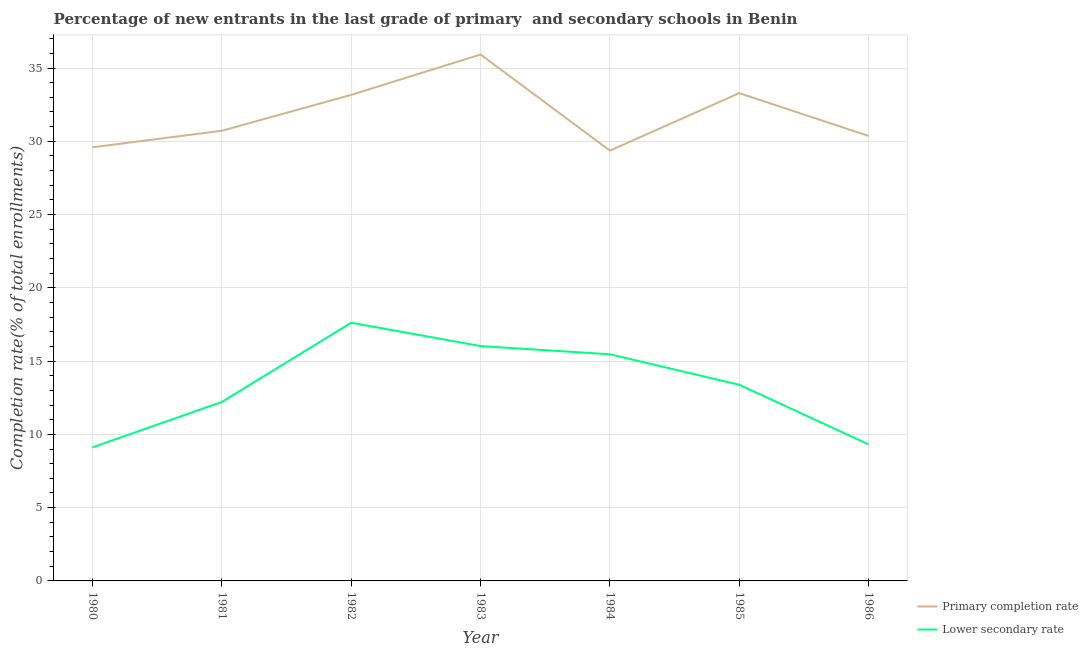How many different coloured lines are there?
Your answer should be compact. 2. Does the line corresponding to completion rate in primary schools intersect with the line corresponding to completion rate in secondary schools?
Provide a short and direct response. No. What is the completion rate in secondary schools in 1980?
Your response must be concise. 9.12. Across all years, what is the maximum completion rate in secondary schools?
Provide a succinct answer. 17.62. Across all years, what is the minimum completion rate in primary schools?
Provide a short and direct response. 29.36. In which year was the completion rate in primary schools maximum?
Ensure brevity in your answer.  1983. What is the total completion rate in secondary schools in the graph?
Offer a very short reply. 93.14. What is the difference between the completion rate in primary schools in 1980 and that in 1982?
Your answer should be compact. -3.58. What is the difference between the completion rate in secondary schools in 1980 and the completion rate in primary schools in 1984?
Offer a very short reply. -20.25. What is the average completion rate in primary schools per year?
Offer a terse response. 31.77. In the year 1981, what is the difference between the completion rate in secondary schools and completion rate in primary schools?
Give a very brief answer. -18.51. What is the ratio of the completion rate in primary schools in 1980 to that in 1981?
Keep it short and to the point. 0.96. Is the completion rate in secondary schools in 1982 less than that in 1983?
Provide a short and direct response. No. What is the difference between the highest and the second highest completion rate in primary schools?
Your answer should be very brief. 2.63. What is the difference between the highest and the lowest completion rate in secondary schools?
Offer a terse response. 8.5. Does the completion rate in primary schools monotonically increase over the years?
Give a very brief answer. No. Is the completion rate in primary schools strictly greater than the completion rate in secondary schools over the years?
Provide a succinct answer. Yes. How many lines are there?
Keep it short and to the point. 2. What is the difference between two consecutive major ticks on the Y-axis?
Provide a succinct answer. 5. Does the graph contain grids?
Offer a very short reply. Yes. How many legend labels are there?
Make the answer very short. 2. What is the title of the graph?
Offer a terse response. Percentage of new entrants in the last grade of primary  and secondary schools in Benin. What is the label or title of the X-axis?
Give a very brief answer. Year. What is the label or title of the Y-axis?
Offer a terse response. Completion rate(% of total enrollments). What is the Completion rate(% of total enrollments) of Primary completion rate in 1980?
Offer a terse response. 29.59. What is the Completion rate(% of total enrollments) in Lower secondary rate in 1980?
Your response must be concise. 9.12. What is the Completion rate(% of total enrollments) in Primary completion rate in 1981?
Offer a terse response. 30.72. What is the Completion rate(% of total enrollments) of Lower secondary rate in 1981?
Give a very brief answer. 12.21. What is the Completion rate(% of total enrollments) in Primary completion rate in 1982?
Your answer should be very brief. 33.17. What is the Completion rate(% of total enrollments) in Lower secondary rate in 1982?
Ensure brevity in your answer.  17.62. What is the Completion rate(% of total enrollments) in Primary completion rate in 1983?
Offer a very short reply. 35.92. What is the Completion rate(% of total enrollments) in Lower secondary rate in 1983?
Your response must be concise. 16.03. What is the Completion rate(% of total enrollments) in Primary completion rate in 1984?
Ensure brevity in your answer.  29.36. What is the Completion rate(% of total enrollments) in Lower secondary rate in 1984?
Offer a very short reply. 15.47. What is the Completion rate(% of total enrollments) of Primary completion rate in 1985?
Ensure brevity in your answer.  33.29. What is the Completion rate(% of total enrollments) in Lower secondary rate in 1985?
Provide a short and direct response. 13.39. What is the Completion rate(% of total enrollments) in Primary completion rate in 1986?
Ensure brevity in your answer.  30.36. What is the Completion rate(% of total enrollments) in Lower secondary rate in 1986?
Ensure brevity in your answer.  9.32. Across all years, what is the maximum Completion rate(% of total enrollments) of Primary completion rate?
Give a very brief answer. 35.92. Across all years, what is the maximum Completion rate(% of total enrollments) in Lower secondary rate?
Give a very brief answer. 17.62. Across all years, what is the minimum Completion rate(% of total enrollments) of Primary completion rate?
Give a very brief answer. 29.36. Across all years, what is the minimum Completion rate(% of total enrollments) of Lower secondary rate?
Ensure brevity in your answer.  9.12. What is the total Completion rate(% of total enrollments) in Primary completion rate in the graph?
Offer a very short reply. 222.41. What is the total Completion rate(% of total enrollments) of Lower secondary rate in the graph?
Offer a terse response. 93.14. What is the difference between the Completion rate(% of total enrollments) of Primary completion rate in 1980 and that in 1981?
Give a very brief answer. -1.13. What is the difference between the Completion rate(% of total enrollments) in Lower secondary rate in 1980 and that in 1981?
Provide a short and direct response. -3.1. What is the difference between the Completion rate(% of total enrollments) of Primary completion rate in 1980 and that in 1982?
Your answer should be compact. -3.58. What is the difference between the Completion rate(% of total enrollments) of Lower secondary rate in 1980 and that in 1982?
Offer a very short reply. -8.5. What is the difference between the Completion rate(% of total enrollments) of Primary completion rate in 1980 and that in 1983?
Offer a very short reply. -6.33. What is the difference between the Completion rate(% of total enrollments) of Lower secondary rate in 1980 and that in 1983?
Offer a very short reply. -6.91. What is the difference between the Completion rate(% of total enrollments) of Primary completion rate in 1980 and that in 1984?
Your response must be concise. 0.23. What is the difference between the Completion rate(% of total enrollments) in Lower secondary rate in 1980 and that in 1984?
Provide a short and direct response. -6.35. What is the difference between the Completion rate(% of total enrollments) of Primary completion rate in 1980 and that in 1985?
Make the answer very short. -3.7. What is the difference between the Completion rate(% of total enrollments) in Lower secondary rate in 1980 and that in 1985?
Your response must be concise. -4.27. What is the difference between the Completion rate(% of total enrollments) of Primary completion rate in 1980 and that in 1986?
Keep it short and to the point. -0.78. What is the difference between the Completion rate(% of total enrollments) of Lower secondary rate in 1980 and that in 1986?
Provide a succinct answer. -0.2. What is the difference between the Completion rate(% of total enrollments) in Primary completion rate in 1981 and that in 1982?
Your answer should be compact. -2.45. What is the difference between the Completion rate(% of total enrollments) of Lower secondary rate in 1981 and that in 1982?
Offer a terse response. -5.41. What is the difference between the Completion rate(% of total enrollments) of Primary completion rate in 1981 and that in 1983?
Ensure brevity in your answer.  -5.2. What is the difference between the Completion rate(% of total enrollments) of Lower secondary rate in 1981 and that in 1983?
Provide a short and direct response. -3.81. What is the difference between the Completion rate(% of total enrollments) in Primary completion rate in 1981 and that in 1984?
Keep it short and to the point. 1.36. What is the difference between the Completion rate(% of total enrollments) in Lower secondary rate in 1981 and that in 1984?
Your response must be concise. -3.26. What is the difference between the Completion rate(% of total enrollments) of Primary completion rate in 1981 and that in 1985?
Ensure brevity in your answer.  -2.57. What is the difference between the Completion rate(% of total enrollments) of Lower secondary rate in 1981 and that in 1985?
Make the answer very short. -1.17. What is the difference between the Completion rate(% of total enrollments) in Primary completion rate in 1981 and that in 1986?
Keep it short and to the point. 0.35. What is the difference between the Completion rate(% of total enrollments) of Lower secondary rate in 1981 and that in 1986?
Offer a very short reply. 2.89. What is the difference between the Completion rate(% of total enrollments) in Primary completion rate in 1982 and that in 1983?
Give a very brief answer. -2.75. What is the difference between the Completion rate(% of total enrollments) in Lower secondary rate in 1982 and that in 1983?
Make the answer very short. 1.59. What is the difference between the Completion rate(% of total enrollments) of Primary completion rate in 1982 and that in 1984?
Your answer should be very brief. 3.81. What is the difference between the Completion rate(% of total enrollments) in Lower secondary rate in 1982 and that in 1984?
Your answer should be very brief. 2.15. What is the difference between the Completion rate(% of total enrollments) of Primary completion rate in 1982 and that in 1985?
Your answer should be very brief. -0.12. What is the difference between the Completion rate(% of total enrollments) in Lower secondary rate in 1982 and that in 1985?
Provide a succinct answer. 4.23. What is the difference between the Completion rate(% of total enrollments) of Primary completion rate in 1982 and that in 1986?
Your response must be concise. 2.8. What is the difference between the Completion rate(% of total enrollments) of Lower secondary rate in 1982 and that in 1986?
Your response must be concise. 8.3. What is the difference between the Completion rate(% of total enrollments) in Primary completion rate in 1983 and that in 1984?
Offer a very short reply. 6.56. What is the difference between the Completion rate(% of total enrollments) in Lower secondary rate in 1983 and that in 1984?
Your answer should be very brief. 0.56. What is the difference between the Completion rate(% of total enrollments) of Primary completion rate in 1983 and that in 1985?
Your answer should be compact. 2.63. What is the difference between the Completion rate(% of total enrollments) of Lower secondary rate in 1983 and that in 1985?
Your answer should be very brief. 2.64. What is the difference between the Completion rate(% of total enrollments) of Primary completion rate in 1983 and that in 1986?
Your answer should be very brief. 5.56. What is the difference between the Completion rate(% of total enrollments) in Lower secondary rate in 1983 and that in 1986?
Provide a succinct answer. 6.71. What is the difference between the Completion rate(% of total enrollments) of Primary completion rate in 1984 and that in 1985?
Your response must be concise. -3.92. What is the difference between the Completion rate(% of total enrollments) of Lower secondary rate in 1984 and that in 1985?
Provide a succinct answer. 2.08. What is the difference between the Completion rate(% of total enrollments) in Primary completion rate in 1984 and that in 1986?
Give a very brief answer. -1. What is the difference between the Completion rate(% of total enrollments) in Lower secondary rate in 1984 and that in 1986?
Your answer should be compact. 6.15. What is the difference between the Completion rate(% of total enrollments) of Primary completion rate in 1985 and that in 1986?
Provide a short and direct response. 2.92. What is the difference between the Completion rate(% of total enrollments) in Lower secondary rate in 1985 and that in 1986?
Keep it short and to the point. 4.07. What is the difference between the Completion rate(% of total enrollments) of Primary completion rate in 1980 and the Completion rate(% of total enrollments) of Lower secondary rate in 1981?
Give a very brief answer. 17.38. What is the difference between the Completion rate(% of total enrollments) in Primary completion rate in 1980 and the Completion rate(% of total enrollments) in Lower secondary rate in 1982?
Offer a very short reply. 11.97. What is the difference between the Completion rate(% of total enrollments) of Primary completion rate in 1980 and the Completion rate(% of total enrollments) of Lower secondary rate in 1983?
Give a very brief answer. 13.56. What is the difference between the Completion rate(% of total enrollments) of Primary completion rate in 1980 and the Completion rate(% of total enrollments) of Lower secondary rate in 1984?
Offer a very short reply. 14.12. What is the difference between the Completion rate(% of total enrollments) in Primary completion rate in 1980 and the Completion rate(% of total enrollments) in Lower secondary rate in 1985?
Make the answer very short. 16.2. What is the difference between the Completion rate(% of total enrollments) of Primary completion rate in 1980 and the Completion rate(% of total enrollments) of Lower secondary rate in 1986?
Your answer should be very brief. 20.27. What is the difference between the Completion rate(% of total enrollments) of Primary completion rate in 1981 and the Completion rate(% of total enrollments) of Lower secondary rate in 1982?
Offer a terse response. 13.1. What is the difference between the Completion rate(% of total enrollments) of Primary completion rate in 1981 and the Completion rate(% of total enrollments) of Lower secondary rate in 1983?
Provide a succinct answer. 14.69. What is the difference between the Completion rate(% of total enrollments) in Primary completion rate in 1981 and the Completion rate(% of total enrollments) in Lower secondary rate in 1984?
Offer a terse response. 15.25. What is the difference between the Completion rate(% of total enrollments) of Primary completion rate in 1981 and the Completion rate(% of total enrollments) of Lower secondary rate in 1985?
Your answer should be very brief. 17.33. What is the difference between the Completion rate(% of total enrollments) of Primary completion rate in 1981 and the Completion rate(% of total enrollments) of Lower secondary rate in 1986?
Ensure brevity in your answer.  21.4. What is the difference between the Completion rate(% of total enrollments) in Primary completion rate in 1982 and the Completion rate(% of total enrollments) in Lower secondary rate in 1983?
Make the answer very short. 17.14. What is the difference between the Completion rate(% of total enrollments) of Primary completion rate in 1982 and the Completion rate(% of total enrollments) of Lower secondary rate in 1984?
Keep it short and to the point. 17.7. What is the difference between the Completion rate(% of total enrollments) of Primary completion rate in 1982 and the Completion rate(% of total enrollments) of Lower secondary rate in 1985?
Your answer should be very brief. 19.78. What is the difference between the Completion rate(% of total enrollments) of Primary completion rate in 1982 and the Completion rate(% of total enrollments) of Lower secondary rate in 1986?
Offer a very short reply. 23.85. What is the difference between the Completion rate(% of total enrollments) in Primary completion rate in 1983 and the Completion rate(% of total enrollments) in Lower secondary rate in 1984?
Your response must be concise. 20.45. What is the difference between the Completion rate(% of total enrollments) in Primary completion rate in 1983 and the Completion rate(% of total enrollments) in Lower secondary rate in 1985?
Give a very brief answer. 22.53. What is the difference between the Completion rate(% of total enrollments) of Primary completion rate in 1983 and the Completion rate(% of total enrollments) of Lower secondary rate in 1986?
Your answer should be very brief. 26.6. What is the difference between the Completion rate(% of total enrollments) of Primary completion rate in 1984 and the Completion rate(% of total enrollments) of Lower secondary rate in 1985?
Your answer should be compact. 15.98. What is the difference between the Completion rate(% of total enrollments) of Primary completion rate in 1984 and the Completion rate(% of total enrollments) of Lower secondary rate in 1986?
Provide a short and direct response. 20.04. What is the difference between the Completion rate(% of total enrollments) of Primary completion rate in 1985 and the Completion rate(% of total enrollments) of Lower secondary rate in 1986?
Your answer should be compact. 23.97. What is the average Completion rate(% of total enrollments) in Primary completion rate per year?
Your answer should be compact. 31.77. What is the average Completion rate(% of total enrollments) of Lower secondary rate per year?
Give a very brief answer. 13.31. In the year 1980, what is the difference between the Completion rate(% of total enrollments) of Primary completion rate and Completion rate(% of total enrollments) of Lower secondary rate?
Your answer should be very brief. 20.47. In the year 1981, what is the difference between the Completion rate(% of total enrollments) of Primary completion rate and Completion rate(% of total enrollments) of Lower secondary rate?
Make the answer very short. 18.51. In the year 1982, what is the difference between the Completion rate(% of total enrollments) in Primary completion rate and Completion rate(% of total enrollments) in Lower secondary rate?
Offer a terse response. 15.55. In the year 1983, what is the difference between the Completion rate(% of total enrollments) in Primary completion rate and Completion rate(% of total enrollments) in Lower secondary rate?
Ensure brevity in your answer.  19.9. In the year 1984, what is the difference between the Completion rate(% of total enrollments) of Primary completion rate and Completion rate(% of total enrollments) of Lower secondary rate?
Make the answer very short. 13.89. In the year 1985, what is the difference between the Completion rate(% of total enrollments) of Primary completion rate and Completion rate(% of total enrollments) of Lower secondary rate?
Provide a short and direct response. 19.9. In the year 1986, what is the difference between the Completion rate(% of total enrollments) of Primary completion rate and Completion rate(% of total enrollments) of Lower secondary rate?
Your response must be concise. 21.05. What is the ratio of the Completion rate(% of total enrollments) in Primary completion rate in 1980 to that in 1981?
Your answer should be compact. 0.96. What is the ratio of the Completion rate(% of total enrollments) of Lower secondary rate in 1980 to that in 1981?
Provide a succinct answer. 0.75. What is the ratio of the Completion rate(% of total enrollments) of Primary completion rate in 1980 to that in 1982?
Offer a very short reply. 0.89. What is the ratio of the Completion rate(% of total enrollments) of Lower secondary rate in 1980 to that in 1982?
Provide a short and direct response. 0.52. What is the ratio of the Completion rate(% of total enrollments) of Primary completion rate in 1980 to that in 1983?
Offer a terse response. 0.82. What is the ratio of the Completion rate(% of total enrollments) of Lower secondary rate in 1980 to that in 1983?
Ensure brevity in your answer.  0.57. What is the ratio of the Completion rate(% of total enrollments) of Primary completion rate in 1980 to that in 1984?
Ensure brevity in your answer.  1.01. What is the ratio of the Completion rate(% of total enrollments) of Lower secondary rate in 1980 to that in 1984?
Give a very brief answer. 0.59. What is the ratio of the Completion rate(% of total enrollments) of Primary completion rate in 1980 to that in 1985?
Ensure brevity in your answer.  0.89. What is the ratio of the Completion rate(% of total enrollments) of Lower secondary rate in 1980 to that in 1985?
Your response must be concise. 0.68. What is the ratio of the Completion rate(% of total enrollments) in Primary completion rate in 1980 to that in 1986?
Provide a succinct answer. 0.97. What is the ratio of the Completion rate(% of total enrollments) of Lower secondary rate in 1980 to that in 1986?
Offer a terse response. 0.98. What is the ratio of the Completion rate(% of total enrollments) of Primary completion rate in 1981 to that in 1982?
Your answer should be very brief. 0.93. What is the ratio of the Completion rate(% of total enrollments) of Lower secondary rate in 1981 to that in 1982?
Provide a short and direct response. 0.69. What is the ratio of the Completion rate(% of total enrollments) in Primary completion rate in 1981 to that in 1983?
Your answer should be very brief. 0.86. What is the ratio of the Completion rate(% of total enrollments) in Lower secondary rate in 1981 to that in 1983?
Offer a very short reply. 0.76. What is the ratio of the Completion rate(% of total enrollments) of Primary completion rate in 1981 to that in 1984?
Offer a terse response. 1.05. What is the ratio of the Completion rate(% of total enrollments) of Lower secondary rate in 1981 to that in 1984?
Make the answer very short. 0.79. What is the ratio of the Completion rate(% of total enrollments) of Primary completion rate in 1981 to that in 1985?
Your response must be concise. 0.92. What is the ratio of the Completion rate(% of total enrollments) of Lower secondary rate in 1981 to that in 1985?
Keep it short and to the point. 0.91. What is the ratio of the Completion rate(% of total enrollments) of Primary completion rate in 1981 to that in 1986?
Make the answer very short. 1.01. What is the ratio of the Completion rate(% of total enrollments) of Lower secondary rate in 1981 to that in 1986?
Ensure brevity in your answer.  1.31. What is the ratio of the Completion rate(% of total enrollments) in Primary completion rate in 1982 to that in 1983?
Keep it short and to the point. 0.92. What is the ratio of the Completion rate(% of total enrollments) of Lower secondary rate in 1982 to that in 1983?
Offer a terse response. 1.1. What is the ratio of the Completion rate(% of total enrollments) in Primary completion rate in 1982 to that in 1984?
Give a very brief answer. 1.13. What is the ratio of the Completion rate(% of total enrollments) of Lower secondary rate in 1982 to that in 1984?
Keep it short and to the point. 1.14. What is the ratio of the Completion rate(% of total enrollments) of Lower secondary rate in 1982 to that in 1985?
Give a very brief answer. 1.32. What is the ratio of the Completion rate(% of total enrollments) of Primary completion rate in 1982 to that in 1986?
Provide a short and direct response. 1.09. What is the ratio of the Completion rate(% of total enrollments) in Lower secondary rate in 1982 to that in 1986?
Offer a very short reply. 1.89. What is the ratio of the Completion rate(% of total enrollments) of Primary completion rate in 1983 to that in 1984?
Keep it short and to the point. 1.22. What is the ratio of the Completion rate(% of total enrollments) of Lower secondary rate in 1983 to that in 1984?
Make the answer very short. 1.04. What is the ratio of the Completion rate(% of total enrollments) of Primary completion rate in 1983 to that in 1985?
Your answer should be compact. 1.08. What is the ratio of the Completion rate(% of total enrollments) of Lower secondary rate in 1983 to that in 1985?
Offer a very short reply. 1.2. What is the ratio of the Completion rate(% of total enrollments) of Primary completion rate in 1983 to that in 1986?
Make the answer very short. 1.18. What is the ratio of the Completion rate(% of total enrollments) in Lower secondary rate in 1983 to that in 1986?
Your answer should be compact. 1.72. What is the ratio of the Completion rate(% of total enrollments) in Primary completion rate in 1984 to that in 1985?
Make the answer very short. 0.88. What is the ratio of the Completion rate(% of total enrollments) of Lower secondary rate in 1984 to that in 1985?
Keep it short and to the point. 1.16. What is the ratio of the Completion rate(% of total enrollments) in Lower secondary rate in 1984 to that in 1986?
Your answer should be very brief. 1.66. What is the ratio of the Completion rate(% of total enrollments) in Primary completion rate in 1985 to that in 1986?
Ensure brevity in your answer.  1.1. What is the ratio of the Completion rate(% of total enrollments) of Lower secondary rate in 1985 to that in 1986?
Your response must be concise. 1.44. What is the difference between the highest and the second highest Completion rate(% of total enrollments) in Primary completion rate?
Your response must be concise. 2.63. What is the difference between the highest and the second highest Completion rate(% of total enrollments) of Lower secondary rate?
Ensure brevity in your answer.  1.59. What is the difference between the highest and the lowest Completion rate(% of total enrollments) in Primary completion rate?
Ensure brevity in your answer.  6.56. What is the difference between the highest and the lowest Completion rate(% of total enrollments) of Lower secondary rate?
Your answer should be very brief. 8.5. 